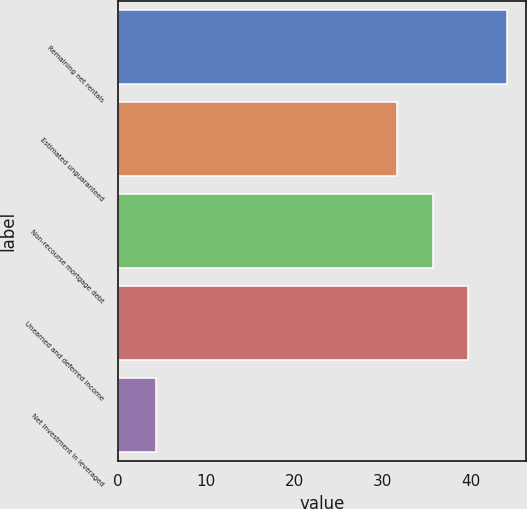Convert chart to OTSL. <chart><loc_0><loc_0><loc_500><loc_500><bar_chart><fcel>Remaining net rentals<fcel>Estimated unguaranteed<fcel>Non-recourse mortgage debt<fcel>Unearned and deferred income<fcel>Net investment in leveraged<nl><fcel>44.1<fcel>31.7<fcel>35.68<fcel>39.66<fcel>4.3<nl></chart> 